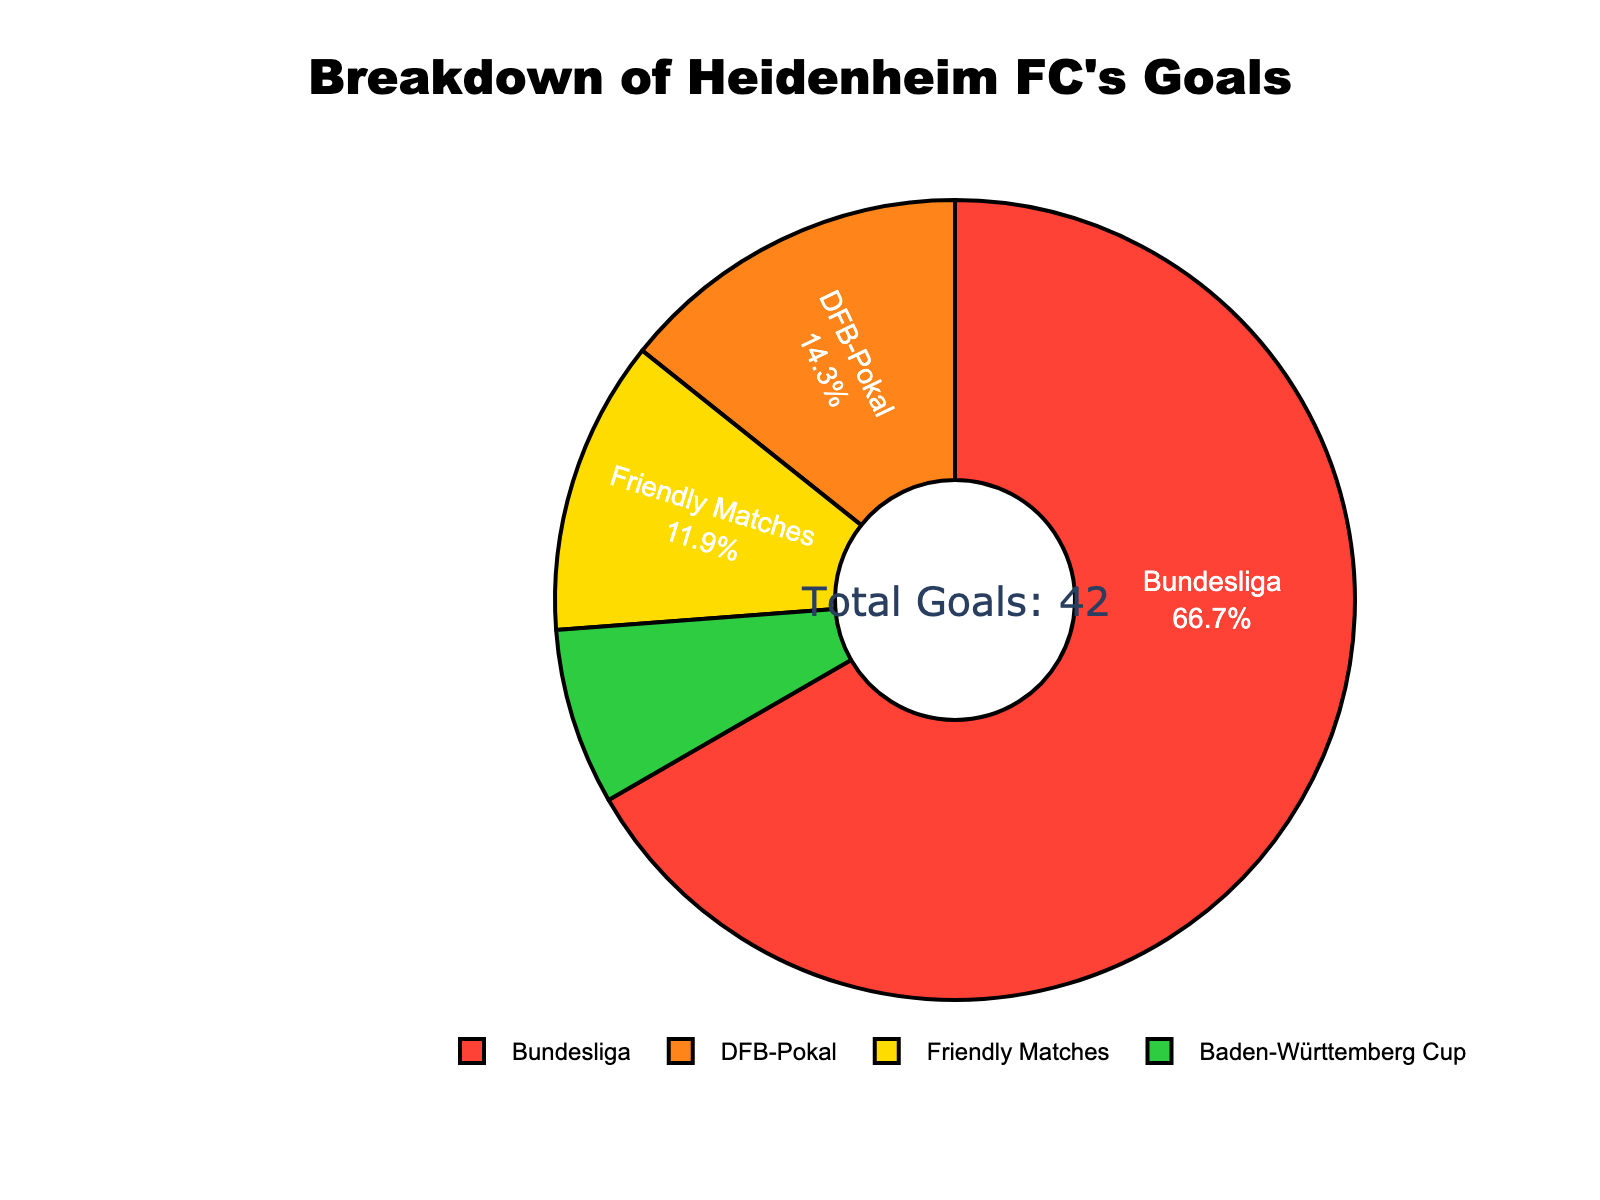What percentage of goals were scored in the Bundesliga? The visual shows a pie chart where the segment labeled "Bundesliga" has the corresponding percentage written inside.
Answer: 70% What is the total number of goals scored across all competitions? The center of the pie chart contains an annotation indicating the total number of goals.
Answer: 42 Which competition has the fewest goals scored? By observing the size of the pie slices and their labels, the Baden-Württemberg Cup slice is the smallest, indicating it has the fewest goals.
Answer: Baden-Württemberg Cup How many more goals were scored in the Bundesliga than in DFB-Pokal? Bundesliga has 28 goals and DFB-Pokal has 6 goals. Subtracting DFB-Pokal goals from Bundesliga goals gives the difference: 28 - 6.
Answer: 22 What fraction of the total goals were scored in Friendly Matches? There are 5 goals in Friendly Matches out of a total of 42 goals; the fraction is 5/42.
Answer: 5/42 Are there more goals in the DFB-Pokal or Baden-Württemberg Cup? By comparing the sizes of the pie segments, the slice for DFB-Pokal is larger than that for Baden-Württemberg Cup.
Answer: DFB-Pokal What is the ratio of Bundesliga goals to Friendly Matches goals? Bundesliga has 28 goals and Friendly Matches have 5 goals. The ratio is 28 to 5 or simplified to 28:5.
Answer: 28:5 What percentage of total goals were scored outside the Bundesliga? Adding up goals from DFB-Pokal, Friendly Matches, and Baden-Württemberg Cup gives 6 + 5 + 3 = 14. The percentage is (14/42) * 100, which is about 33.33%.
Answer: 33.33% Which two competitions together make up more than a third of the total goals? The total goals are 42. Two competitions that together account for more than 14 goals (one-third of 42) are Bundesliga (28 goals) and DFB-Pokal (6 goals).
Answer: Bundesliga and DFB-Pokal If the goals scored in Friendly Matches were doubled, what would be the new total of goals? Doubling the Friendly Matches goals means 5 * 2 = 10. Adding the new total to the previous tally without Friendly Matches gives 28 (Bundesliga) + 6 (DFB-Pokal) + 3 (Baden-Württemberg Cup) + 10 (new Friendly Matches); summing these gives 47 goals.
Answer: 47 